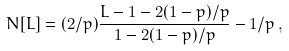Convert formula to latex. <formula><loc_0><loc_0><loc_500><loc_500>N [ L ] = ( 2 / p ) \frac { L - 1 - 2 ( 1 - p ) / p } { 1 - 2 ( 1 - p ) / p } - 1 / p \, ,</formula> 